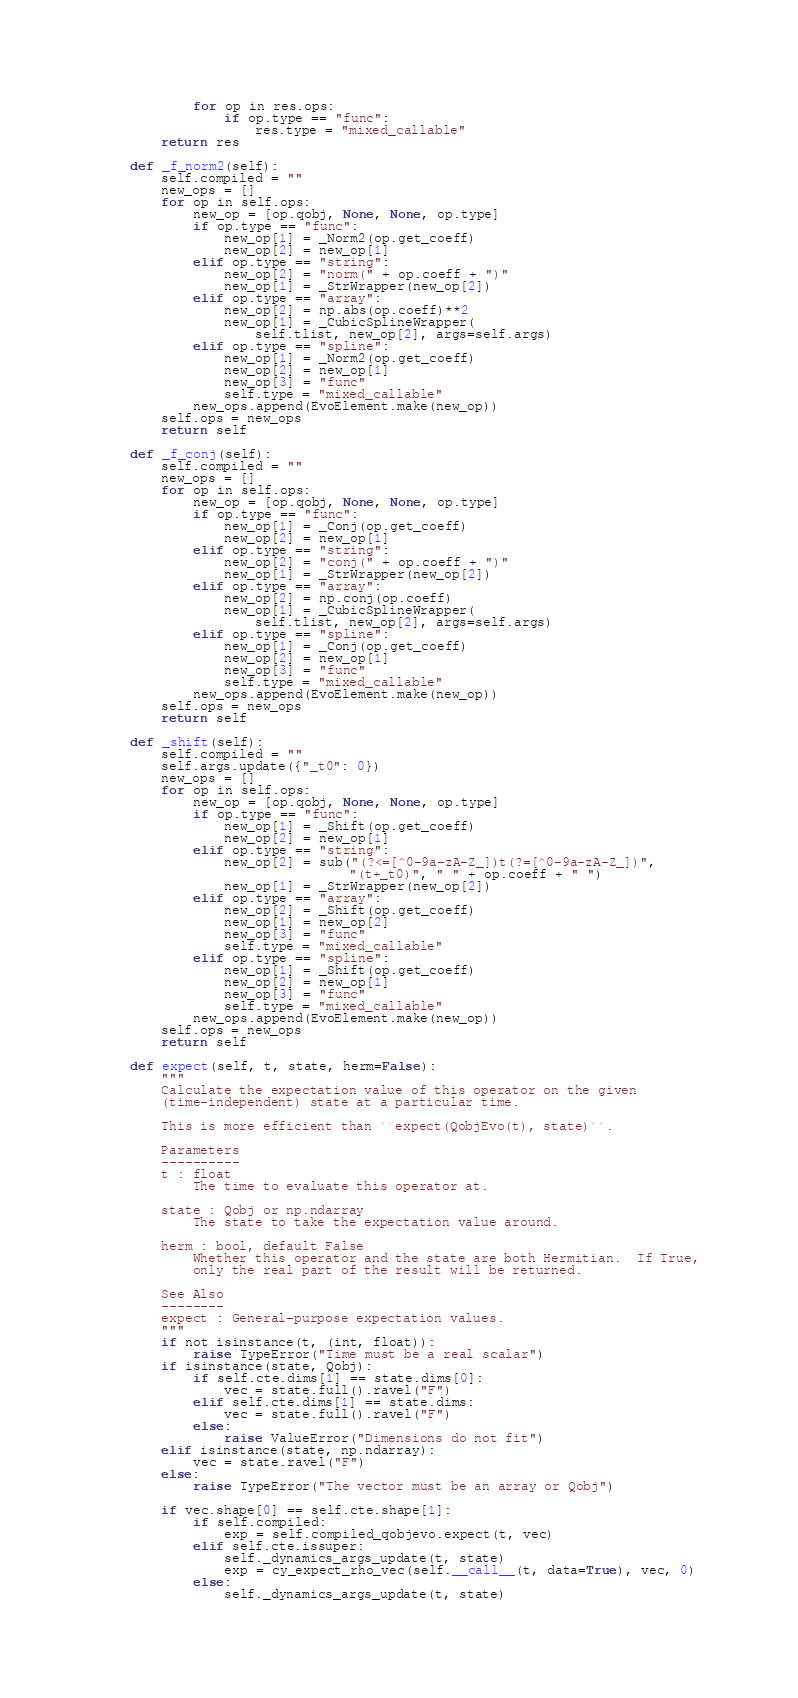<code> <loc_0><loc_0><loc_500><loc_500><_Python_>            for op in res.ops:
                if op.type == "func":
                    res.type = "mixed_callable"
        return res

    def _f_norm2(self):
        self.compiled = ""
        new_ops = []
        for op in self.ops:
            new_op = [op.qobj, None, None, op.type]
            if op.type == "func":
                new_op[1] = _Norm2(op.get_coeff)
                new_op[2] = new_op[1]
            elif op.type == "string":
                new_op[2] = "norm(" + op.coeff + ")"
                new_op[1] = _StrWrapper(new_op[2])
            elif op.type == "array":
                new_op[2] = np.abs(op.coeff)**2
                new_op[1] = _CubicSplineWrapper(
                    self.tlist, new_op[2], args=self.args)
            elif op.type == "spline":
                new_op[1] = _Norm2(op.get_coeff)
                new_op[2] = new_op[1]
                new_op[3] = "func"
                self.type = "mixed_callable"
            new_ops.append(EvoElement.make(new_op))
        self.ops = new_ops
        return self

    def _f_conj(self):
        self.compiled = ""
        new_ops = []
        for op in self.ops:
            new_op = [op.qobj, None, None, op.type]
            if op.type == "func":
                new_op[1] = _Conj(op.get_coeff)
                new_op[2] = new_op[1]
            elif op.type == "string":
                new_op[2] = "conj(" + op.coeff + ")"
                new_op[1] = _StrWrapper(new_op[2])
            elif op.type == "array":
                new_op[2] = np.conj(op.coeff)
                new_op[1] = _CubicSplineWrapper(
                    self.tlist, new_op[2], args=self.args)
            elif op.type == "spline":
                new_op[1] = _Conj(op.get_coeff)
                new_op[2] = new_op[1]
                new_op[3] = "func"
                self.type = "mixed_callable"
            new_ops.append(EvoElement.make(new_op))
        self.ops = new_ops
        return self

    def _shift(self):
        self.compiled = ""
        self.args.update({"_t0": 0})
        new_ops = []
        for op in self.ops:
            new_op = [op.qobj, None, None, op.type]
            if op.type == "func":
                new_op[1] = _Shift(op.get_coeff)
                new_op[2] = new_op[1]
            elif op.type == "string":
                new_op[2] = sub("(?<=[^0-9a-zA-Z_])t(?=[^0-9a-zA-Z_])",
                                "(t+_t0)", " " + op.coeff + " ")
                new_op[1] = _StrWrapper(new_op[2])
            elif op.type == "array":
                new_op[2] = _Shift(op.get_coeff)
                new_op[1] = new_op[2]
                new_op[3] = "func"
                self.type = "mixed_callable"
            elif op.type == "spline":
                new_op[1] = _Shift(op.get_coeff)
                new_op[2] = new_op[1]
                new_op[3] = "func"
                self.type = "mixed_callable"
            new_ops.append(EvoElement.make(new_op))
        self.ops = new_ops
        return self

    def expect(self, t, state, herm=False):
        """
        Calculate the expectation value of this operator on the given
        (time-independent) state at a particular time.

        This is more efficient than ``expect(QobjEvo(t), state)``.

        Parameters
        ----------
        t : float
            The time to evaluate this operator at.

        state : Qobj or np.ndarray
            The state to take the expectation value around.

        herm : bool, default False
            Whether this operator and the state are both Hermitian.  If True,
            only the real part of the result will be returned.

        See Also
        --------
        expect : General-purpose expectation values.
        """
        if not isinstance(t, (int, float)):
            raise TypeError("Time must be a real scalar")
        if isinstance(state, Qobj):
            if self.cte.dims[1] == state.dims[0]:
                vec = state.full().ravel("F")
            elif self.cte.dims[1] == state.dims:
                vec = state.full().ravel("F")
            else:
                raise ValueError("Dimensions do not fit")
        elif isinstance(state, np.ndarray):
            vec = state.ravel("F")
        else:
            raise TypeError("The vector must be an array or Qobj")

        if vec.shape[0] == self.cte.shape[1]:
            if self.compiled:
                exp = self.compiled_qobjevo.expect(t, vec)
            elif self.cte.issuper:
                self._dynamics_args_update(t, state)
                exp = cy_expect_rho_vec(self.__call__(t, data=True), vec, 0)
            else:
                self._dynamics_args_update(t, state)</code> 